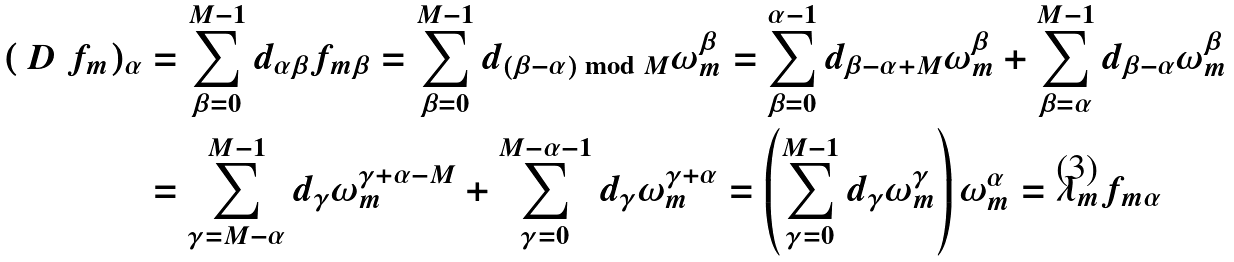<formula> <loc_0><loc_0><loc_500><loc_500>( \ D \ f _ { m } ) _ { \alpha } & = \sum ^ { M - 1 } _ { \beta = 0 } { d _ { \alpha \beta } f _ { m \beta } } = \sum ^ { M - 1 } _ { \beta = 0 } { d _ { ( \beta - \alpha ) \bmod M } \omega ^ { \beta } _ { m } } = \sum ^ { \alpha - 1 } _ { \beta = 0 } { d _ { \beta - \alpha + M } \omega ^ { \beta } _ { m } } + \sum ^ { M - 1 } _ { \beta = \alpha } { d _ { \beta - \alpha } \omega ^ { \beta } _ { m } } \\ & = \sum ^ { M - 1 } _ { \gamma = M - \alpha } { d _ { \gamma } \omega ^ { \gamma + \alpha - M } _ { m } } + \sum ^ { M - \alpha - 1 } _ { \gamma = 0 } { d _ { \gamma } \omega ^ { \gamma + \alpha } _ { m } } = \left ( \sum ^ { M - 1 } _ { \gamma = 0 } { d _ { \gamma } \omega ^ { \gamma } _ { m } } \right ) \omega ^ { \alpha } _ { m } = \lambda _ { m } f _ { m \alpha }</formula> 